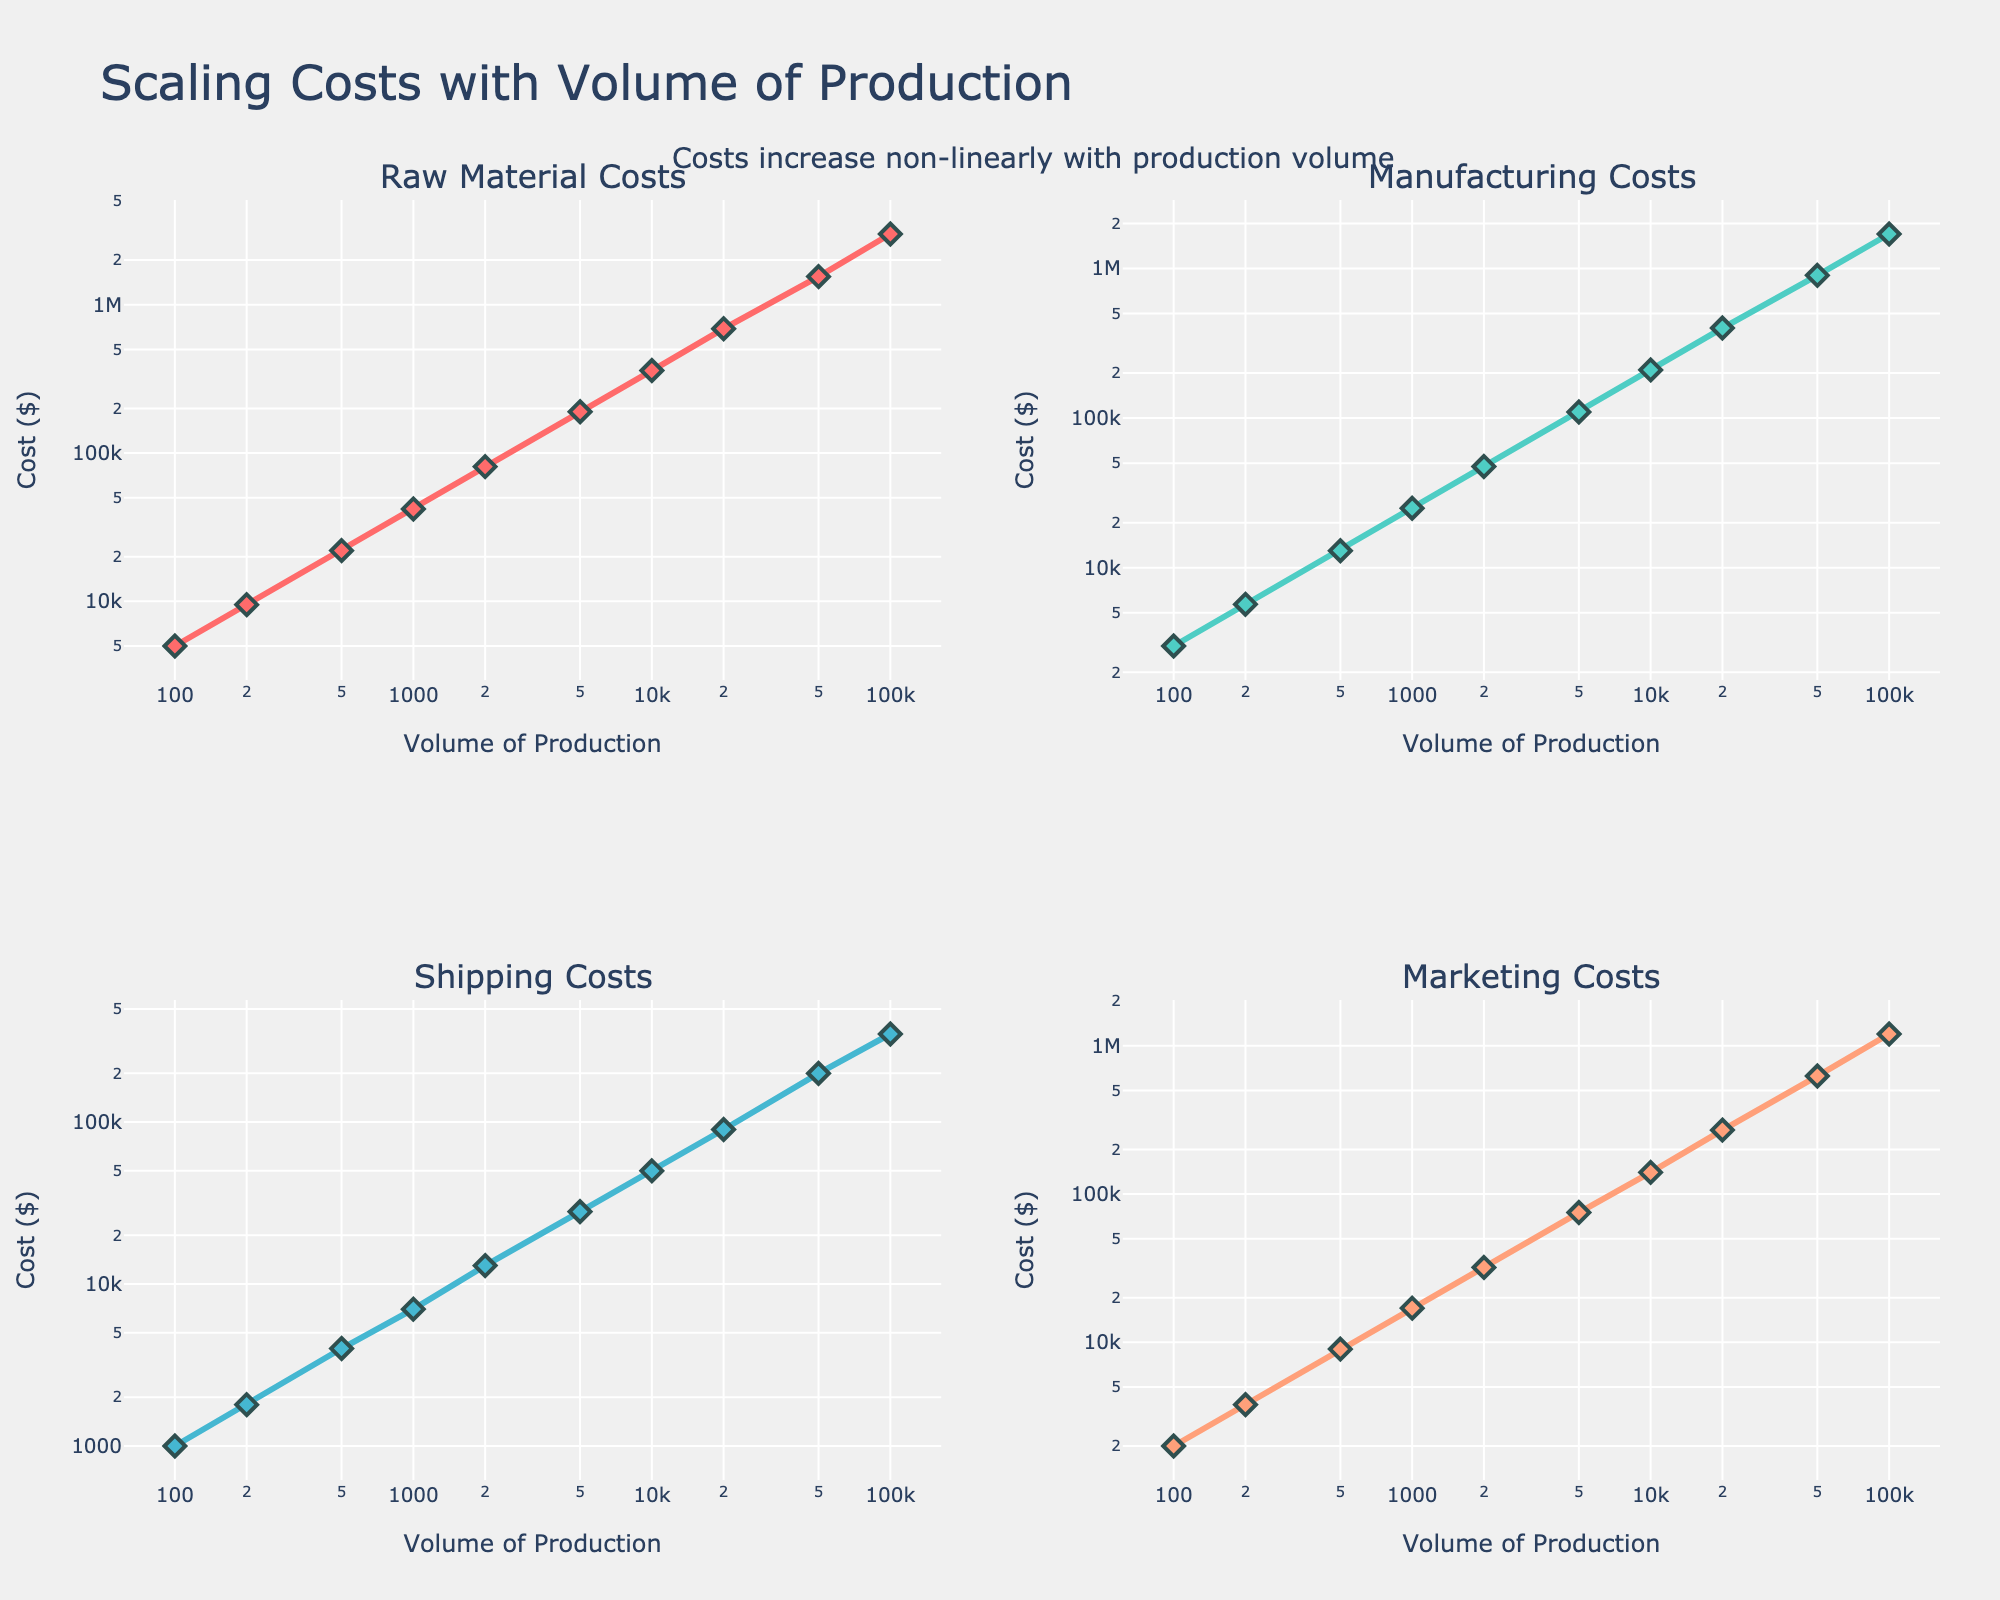What is the title of the figure? The title of the figure is typically found at the top. In this subplot, it reads "Scaling Costs with Volume of Production" which indicates the subject of the plot.
Answer: Scaling Costs with Volume of Production How many cost categories are visualized? There are four subplots, each titled after a different cost category: "Raw Material Costs", "Manufacturing Costs", "Shipping Costs", and "Marketing Costs". This way, we understand that four cost categories are visualized.
Answer: Four What is the color of the line representing Manufacturing Costs? In the corresponding subplot, the line representing Manufacturing Costs is colored in a distinctive shade. According to the data code, the color assigned to Manufacturing Costs is '#4ECDC4', which appears visually as a teal color.
Answer: Teal Between which production volumes do the Marketing Costs exceed $100,000? Marketing Costs are plotted on a logarithmic scale. From visual inspection, we see that the Marketing Costs exceed $100,000 between production volumes of about 20,000 and 100,000 units.
Answer: Between 20,000 and 100,000 Which cost category increases the least exponentially with production volume? All costs are plotted on a logarithmic scale, showing non-linear growth. By comparing subplots, Shipping Costs appear to have a less steep curve compared to Raw Material, Manufacturing, and Marketing Costs, indicating the least exponential increase.
Answer: Shipping Costs At what volume of production do Raw Material Costs surpass $1,000,000? By examining the logarithmic plot for Raw Material Costs, we observe that Costs surpass $1,000,000 when production volume reaches around 50,000 units.
Answer: 50,000 units What is the approximate increase in Total Costs between production volumes of 1,000 and 10,000? We must add the costs for Raw Material, Manufacturing, Shipping, and Marketing at both production volumes and then subtract to find the total increase. Total Costs at 1,000 units: $91,000. Total Costs at 10,000 units: $760,000. The increase is $760,000 - $91,000 = $669,000.
Answer: $669,000 What pattern do the cost curves generally follow across different volumes of production? By examining the logarithmic axes and the subplots' trends, we observe that all cost categories exhibit a non-linear growth or exponential growth pattern as the volume of production increases.
Answer: Non-linear growth Among all cost categories, which one shows the highest absolute increase in costs when moving from 1,000 to 10,000 units? We need to look at the absolute values at 1,000 and 10,000 units for each category and find the differences. Raw Material Costs show the highest increase: $360,000 - $42,000 = $318,000.
Answer: Raw Material Costs 